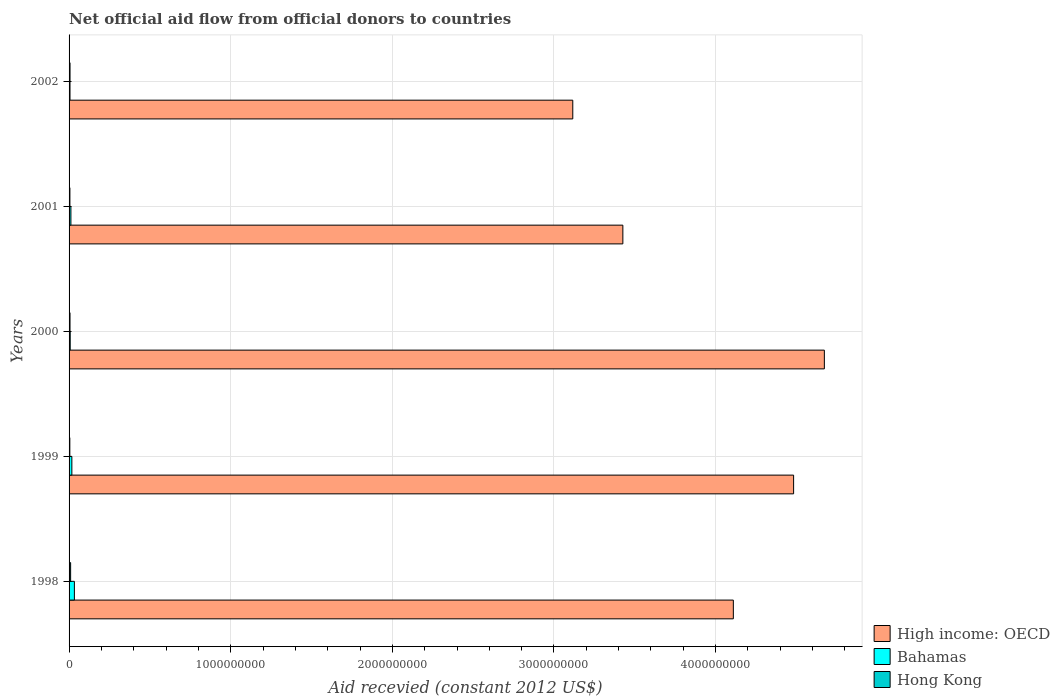Are the number of bars per tick equal to the number of legend labels?
Keep it short and to the point. Yes. Are the number of bars on each tick of the Y-axis equal?
Provide a short and direct response. Yes. How many bars are there on the 3rd tick from the top?
Your answer should be very brief. 3. In how many cases, is the number of bars for a given year not equal to the number of legend labels?
Your answer should be very brief. 0. What is the total aid received in Hong Kong in 1998?
Keep it short and to the point. 9.64e+06. Across all years, what is the maximum total aid received in Bahamas?
Provide a succinct answer. 3.29e+07. Across all years, what is the minimum total aid received in Bahamas?
Your answer should be very brief. 5.78e+06. In which year was the total aid received in Bahamas maximum?
Give a very brief answer. 1998. In which year was the total aid received in High income: OECD minimum?
Keep it short and to the point. 2002. What is the total total aid received in High income: OECD in the graph?
Keep it short and to the point. 1.98e+1. What is the difference between the total aid received in Hong Kong in 1998 and that in 2002?
Make the answer very short. 3.72e+06. What is the difference between the total aid received in Hong Kong in 1998 and the total aid received in Bahamas in 2002?
Offer a very short reply. 3.86e+06. What is the average total aid received in Bahamas per year?
Your answer should be very brief. 1.49e+07. In the year 2002, what is the difference between the total aid received in Hong Kong and total aid received in High income: OECD?
Keep it short and to the point. -3.11e+09. What is the ratio of the total aid received in High income: OECD in 1999 to that in 2002?
Offer a terse response. 1.44. Is the difference between the total aid received in Hong Kong in 2000 and 2002 greater than the difference between the total aid received in High income: OECD in 2000 and 2002?
Make the answer very short. No. What is the difference between the highest and the second highest total aid received in Bahamas?
Ensure brevity in your answer.  1.57e+07. What is the difference between the highest and the lowest total aid received in Hong Kong?
Provide a succinct answer. 4.91e+06. In how many years, is the total aid received in High income: OECD greater than the average total aid received in High income: OECD taken over all years?
Provide a succinct answer. 3. What does the 3rd bar from the top in 2002 represents?
Offer a terse response. High income: OECD. What does the 3rd bar from the bottom in 2002 represents?
Your answer should be compact. Hong Kong. How many bars are there?
Offer a terse response. 15. Does the graph contain grids?
Keep it short and to the point. Yes. Where does the legend appear in the graph?
Your answer should be compact. Bottom right. How are the legend labels stacked?
Keep it short and to the point. Vertical. What is the title of the graph?
Your response must be concise. Net official aid flow from official donors to countries. Does "Korea (Democratic)" appear as one of the legend labels in the graph?
Offer a very short reply. No. What is the label or title of the X-axis?
Your answer should be compact. Aid recevied (constant 2012 US$). What is the label or title of the Y-axis?
Provide a short and direct response. Years. What is the Aid recevied (constant 2012 US$) of High income: OECD in 1998?
Ensure brevity in your answer.  4.11e+09. What is the Aid recevied (constant 2012 US$) in Bahamas in 1998?
Provide a short and direct response. 3.29e+07. What is the Aid recevied (constant 2012 US$) of Hong Kong in 1998?
Your response must be concise. 9.64e+06. What is the Aid recevied (constant 2012 US$) in High income: OECD in 1999?
Your response must be concise. 4.48e+09. What is the Aid recevied (constant 2012 US$) in Bahamas in 1999?
Your answer should be very brief. 1.72e+07. What is the Aid recevied (constant 2012 US$) of Hong Kong in 1999?
Provide a succinct answer. 4.73e+06. What is the Aid recevied (constant 2012 US$) in High income: OECD in 2000?
Offer a terse response. 4.67e+09. What is the Aid recevied (constant 2012 US$) of Bahamas in 2000?
Give a very brief answer. 7.08e+06. What is the Aid recevied (constant 2012 US$) in Hong Kong in 2000?
Your response must be concise. 5.83e+06. What is the Aid recevied (constant 2012 US$) of High income: OECD in 2001?
Your answer should be compact. 3.43e+09. What is the Aid recevied (constant 2012 US$) in Bahamas in 2001?
Your answer should be very brief. 1.14e+07. What is the Aid recevied (constant 2012 US$) in Hong Kong in 2001?
Give a very brief answer. 5.12e+06. What is the Aid recevied (constant 2012 US$) in High income: OECD in 2002?
Provide a short and direct response. 3.12e+09. What is the Aid recevied (constant 2012 US$) of Bahamas in 2002?
Offer a very short reply. 5.78e+06. What is the Aid recevied (constant 2012 US$) of Hong Kong in 2002?
Your answer should be compact. 5.92e+06. Across all years, what is the maximum Aid recevied (constant 2012 US$) in High income: OECD?
Provide a succinct answer. 4.67e+09. Across all years, what is the maximum Aid recevied (constant 2012 US$) in Bahamas?
Give a very brief answer. 3.29e+07. Across all years, what is the maximum Aid recevied (constant 2012 US$) of Hong Kong?
Offer a very short reply. 9.64e+06. Across all years, what is the minimum Aid recevied (constant 2012 US$) of High income: OECD?
Your answer should be very brief. 3.12e+09. Across all years, what is the minimum Aid recevied (constant 2012 US$) in Bahamas?
Make the answer very short. 5.78e+06. Across all years, what is the minimum Aid recevied (constant 2012 US$) of Hong Kong?
Provide a succinct answer. 4.73e+06. What is the total Aid recevied (constant 2012 US$) in High income: OECD in the graph?
Your response must be concise. 1.98e+1. What is the total Aid recevied (constant 2012 US$) of Bahamas in the graph?
Make the answer very short. 7.44e+07. What is the total Aid recevied (constant 2012 US$) of Hong Kong in the graph?
Make the answer very short. 3.12e+07. What is the difference between the Aid recevied (constant 2012 US$) of High income: OECD in 1998 and that in 1999?
Give a very brief answer. -3.73e+08. What is the difference between the Aid recevied (constant 2012 US$) in Bahamas in 1998 and that in 1999?
Your answer should be very brief. 1.57e+07. What is the difference between the Aid recevied (constant 2012 US$) in Hong Kong in 1998 and that in 1999?
Ensure brevity in your answer.  4.91e+06. What is the difference between the Aid recevied (constant 2012 US$) in High income: OECD in 1998 and that in 2000?
Offer a terse response. -5.63e+08. What is the difference between the Aid recevied (constant 2012 US$) of Bahamas in 1998 and that in 2000?
Provide a short and direct response. 2.58e+07. What is the difference between the Aid recevied (constant 2012 US$) in Hong Kong in 1998 and that in 2000?
Your response must be concise. 3.81e+06. What is the difference between the Aid recevied (constant 2012 US$) in High income: OECD in 1998 and that in 2001?
Offer a terse response. 6.84e+08. What is the difference between the Aid recevied (constant 2012 US$) in Bahamas in 1998 and that in 2001?
Offer a terse response. 2.15e+07. What is the difference between the Aid recevied (constant 2012 US$) in Hong Kong in 1998 and that in 2001?
Offer a terse response. 4.52e+06. What is the difference between the Aid recevied (constant 2012 US$) of High income: OECD in 1998 and that in 2002?
Your answer should be very brief. 9.93e+08. What is the difference between the Aid recevied (constant 2012 US$) in Bahamas in 1998 and that in 2002?
Your response must be concise. 2.71e+07. What is the difference between the Aid recevied (constant 2012 US$) in Hong Kong in 1998 and that in 2002?
Ensure brevity in your answer.  3.72e+06. What is the difference between the Aid recevied (constant 2012 US$) of High income: OECD in 1999 and that in 2000?
Your answer should be very brief. -1.90e+08. What is the difference between the Aid recevied (constant 2012 US$) in Bahamas in 1999 and that in 2000?
Your response must be concise. 1.02e+07. What is the difference between the Aid recevied (constant 2012 US$) in Hong Kong in 1999 and that in 2000?
Ensure brevity in your answer.  -1.10e+06. What is the difference between the Aid recevied (constant 2012 US$) of High income: OECD in 1999 and that in 2001?
Keep it short and to the point. 1.06e+09. What is the difference between the Aid recevied (constant 2012 US$) of Bahamas in 1999 and that in 2001?
Your answer should be compact. 5.86e+06. What is the difference between the Aid recevied (constant 2012 US$) of Hong Kong in 1999 and that in 2001?
Offer a terse response. -3.90e+05. What is the difference between the Aid recevied (constant 2012 US$) of High income: OECD in 1999 and that in 2002?
Offer a very short reply. 1.37e+09. What is the difference between the Aid recevied (constant 2012 US$) in Bahamas in 1999 and that in 2002?
Your response must be concise. 1.15e+07. What is the difference between the Aid recevied (constant 2012 US$) of Hong Kong in 1999 and that in 2002?
Give a very brief answer. -1.19e+06. What is the difference between the Aid recevied (constant 2012 US$) of High income: OECD in 2000 and that in 2001?
Provide a succinct answer. 1.25e+09. What is the difference between the Aid recevied (constant 2012 US$) of Bahamas in 2000 and that in 2001?
Your response must be concise. -4.30e+06. What is the difference between the Aid recevied (constant 2012 US$) in Hong Kong in 2000 and that in 2001?
Your answer should be very brief. 7.10e+05. What is the difference between the Aid recevied (constant 2012 US$) in High income: OECD in 2000 and that in 2002?
Keep it short and to the point. 1.56e+09. What is the difference between the Aid recevied (constant 2012 US$) of Bahamas in 2000 and that in 2002?
Your response must be concise. 1.30e+06. What is the difference between the Aid recevied (constant 2012 US$) of Hong Kong in 2000 and that in 2002?
Give a very brief answer. -9.00e+04. What is the difference between the Aid recevied (constant 2012 US$) in High income: OECD in 2001 and that in 2002?
Provide a succinct answer. 3.10e+08. What is the difference between the Aid recevied (constant 2012 US$) of Bahamas in 2001 and that in 2002?
Your answer should be compact. 5.60e+06. What is the difference between the Aid recevied (constant 2012 US$) in Hong Kong in 2001 and that in 2002?
Your answer should be compact. -8.00e+05. What is the difference between the Aid recevied (constant 2012 US$) in High income: OECD in 1998 and the Aid recevied (constant 2012 US$) in Bahamas in 1999?
Ensure brevity in your answer.  4.09e+09. What is the difference between the Aid recevied (constant 2012 US$) in High income: OECD in 1998 and the Aid recevied (constant 2012 US$) in Hong Kong in 1999?
Keep it short and to the point. 4.10e+09. What is the difference between the Aid recevied (constant 2012 US$) of Bahamas in 1998 and the Aid recevied (constant 2012 US$) of Hong Kong in 1999?
Ensure brevity in your answer.  2.82e+07. What is the difference between the Aid recevied (constant 2012 US$) of High income: OECD in 1998 and the Aid recevied (constant 2012 US$) of Bahamas in 2000?
Give a very brief answer. 4.10e+09. What is the difference between the Aid recevied (constant 2012 US$) of High income: OECD in 1998 and the Aid recevied (constant 2012 US$) of Hong Kong in 2000?
Provide a short and direct response. 4.10e+09. What is the difference between the Aid recevied (constant 2012 US$) of Bahamas in 1998 and the Aid recevied (constant 2012 US$) of Hong Kong in 2000?
Make the answer very short. 2.71e+07. What is the difference between the Aid recevied (constant 2012 US$) of High income: OECD in 1998 and the Aid recevied (constant 2012 US$) of Bahamas in 2001?
Your answer should be very brief. 4.10e+09. What is the difference between the Aid recevied (constant 2012 US$) of High income: OECD in 1998 and the Aid recevied (constant 2012 US$) of Hong Kong in 2001?
Provide a short and direct response. 4.10e+09. What is the difference between the Aid recevied (constant 2012 US$) of Bahamas in 1998 and the Aid recevied (constant 2012 US$) of Hong Kong in 2001?
Keep it short and to the point. 2.78e+07. What is the difference between the Aid recevied (constant 2012 US$) of High income: OECD in 1998 and the Aid recevied (constant 2012 US$) of Bahamas in 2002?
Your answer should be very brief. 4.10e+09. What is the difference between the Aid recevied (constant 2012 US$) in High income: OECD in 1998 and the Aid recevied (constant 2012 US$) in Hong Kong in 2002?
Offer a terse response. 4.10e+09. What is the difference between the Aid recevied (constant 2012 US$) of Bahamas in 1998 and the Aid recevied (constant 2012 US$) of Hong Kong in 2002?
Provide a succinct answer. 2.70e+07. What is the difference between the Aid recevied (constant 2012 US$) of High income: OECD in 1999 and the Aid recevied (constant 2012 US$) of Bahamas in 2000?
Provide a short and direct response. 4.48e+09. What is the difference between the Aid recevied (constant 2012 US$) in High income: OECD in 1999 and the Aid recevied (constant 2012 US$) in Hong Kong in 2000?
Your answer should be very brief. 4.48e+09. What is the difference between the Aid recevied (constant 2012 US$) in Bahamas in 1999 and the Aid recevied (constant 2012 US$) in Hong Kong in 2000?
Offer a very short reply. 1.14e+07. What is the difference between the Aid recevied (constant 2012 US$) of High income: OECD in 1999 and the Aid recevied (constant 2012 US$) of Bahamas in 2001?
Your answer should be very brief. 4.47e+09. What is the difference between the Aid recevied (constant 2012 US$) of High income: OECD in 1999 and the Aid recevied (constant 2012 US$) of Hong Kong in 2001?
Give a very brief answer. 4.48e+09. What is the difference between the Aid recevied (constant 2012 US$) of Bahamas in 1999 and the Aid recevied (constant 2012 US$) of Hong Kong in 2001?
Keep it short and to the point. 1.21e+07. What is the difference between the Aid recevied (constant 2012 US$) in High income: OECD in 1999 and the Aid recevied (constant 2012 US$) in Bahamas in 2002?
Ensure brevity in your answer.  4.48e+09. What is the difference between the Aid recevied (constant 2012 US$) in High income: OECD in 1999 and the Aid recevied (constant 2012 US$) in Hong Kong in 2002?
Make the answer very short. 4.48e+09. What is the difference between the Aid recevied (constant 2012 US$) in Bahamas in 1999 and the Aid recevied (constant 2012 US$) in Hong Kong in 2002?
Keep it short and to the point. 1.13e+07. What is the difference between the Aid recevied (constant 2012 US$) in High income: OECD in 2000 and the Aid recevied (constant 2012 US$) in Bahamas in 2001?
Your answer should be compact. 4.66e+09. What is the difference between the Aid recevied (constant 2012 US$) of High income: OECD in 2000 and the Aid recevied (constant 2012 US$) of Hong Kong in 2001?
Your answer should be very brief. 4.67e+09. What is the difference between the Aid recevied (constant 2012 US$) in Bahamas in 2000 and the Aid recevied (constant 2012 US$) in Hong Kong in 2001?
Make the answer very short. 1.96e+06. What is the difference between the Aid recevied (constant 2012 US$) in High income: OECD in 2000 and the Aid recevied (constant 2012 US$) in Bahamas in 2002?
Offer a terse response. 4.67e+09. What is the difference between the Aid recevied (constant 2012 US$) of High income: OECD in 2000 and the Aid recevied (constant 2012 US$) of Hong Kong in 2002?
Your answer should be compact. 4.67e+09. What is the difference between the Aid recevied (constant 2012 US$) in Bahamas in 2000 and the Aid recevied (constant 2012 US$) in Hong Kong in 2002?
Make the answer very short. 1.16e+06. What is the difference between the Aid recevied (constant 2012 US$) in High income: OECD in 2001 and the Aid recevied (constant 2012 US$) in Bahamas in 2002?
Offer a very short reply. 3.42e+09. What is the difference between the Aid recevied (constant 2012 US$) of High income: OECD in 2001 and the Aid recevied (constant 2012 US$) of Hong Kong in 2002?
Your response must be concise. 3.42e+09. What is the difference between the Aid recevied (constant 2012 US$) of Bahamas in 2001 and the Aid recevied (constant 2012 US$) of Hong Kong in 2002?
Offer a terse response. 5.46e+06. What is the average Aid recevied (constant 2012 US$) of High income: OECD per year?
Your answer should be compact. 3.96e+09. What is the average Aid recevied (constant 2012 US$) in Bahamas per year?
Keep it short and to the point. 1.49e+07. What is the average Aid recevied (constant 2012 US$) in Hong Kong per year?
Offer a very short reply. 6.25e+06. In the year 1998, what is the difference between the Aid recevied (constant 2012 US$) in High income: OECD and Aid recevied (constant 2012 US$) in Bahamas?
Offer a terse response. 4.08e+09. In the year 1998, what is the difference between the Aid recevied (constant 2012 US$) in High income: OECD and Aid recevied (constant 2012 US$) in Hong Kong?
Make the answer very short. 4.10e+09. In the year 1998, what is the difference between the Aid recevied (constant 2012 US$) of Bahamas and Aid recevied (constant 2012 US$) of Hong Kong?
Offer a very short reply. 2.33e+07. In the year 1999, what is the difference between the Aid recevied (constant 2012 US$) in High income: OECD and Aid recevied (constant 2012 US$) in Bahamas?
Provide a succinct answer. 4.47e+09. In the year 1999, what is the difference between the Aid recevied (constant 2012 US$) in High income: OECD and Aid recevied (constant 2012 US$) in Hong Kong?
Your answer should be compact. 4.48e+09. In the year 1999, what is the difference between the Aid recevied (constant 2012 US$) of Bahamas and Aid recevied (constant 2012 US$) of Hong Kong?
Your answer should be compact. 1.25e+07. In the year 2000, what is the difference between the Aid recevied (constant 2012 US$) of High income: OECD and Aid recevied (constant 2012 US$) of Bahamas?
Your answer should be compact. 4.67e+09. In the year 2000, what is the difference between the Aid recevied (constant 2012 US$) in High income: OECD and Aid recevied (constant 2012 US$) in Hong Kong?
Offer a very short reply. 4.67e+09. In the year 2000, what is the difference between the Aid recevied (constant 2012 US$) in Bahamas and Aid recevied (constant 2012 US$) in Hong Kong?
Your answer should be compact. 1.25e+06. In the year 2001, what is the difference between the Aid recevied (constant 2012 US$) of High income: OECD and Aid recevied (constant 2012 US$) of Bahamas?
Give a very brief answer. 3.41e+09. In the year 2001, what is the difference between the Aid recevied (constant 2012 US$) of High income: OECD and Aid recevied (constant 2012 US$) of Hong Kong?
Offer a very short reply. 3.42e+09. In the year 2001, what is the difference between the Aid recevied (constant 2012 US$) of Bahamas and Aid recevied (constant 2012 US$) of Hong Kong?
Offer a terse response. 6.26e+06. In the year 2002, what is the difference between the Aid recevied (constant 2012 US$) of High income: OECD and Aid recevied (constant 2012 US$) of Bahamas?
Make the answer very short. 3.11e+09. In the year 2002, what is the difference between the Aid recevied (constant 2012 US$) in High income: OECD and Aid recevied (constant 2012 US$) in Hong Kong?
Provide a short and direct response. 3.11e+09. What is the ratio of the Aid recevied (constant 2012 US$) of High income: OECD in 1998 to that in 1999?
Your response must be concise. 0.92. What is the ratio of the Aid recevied (constant 2012 US$) of Bahamas in 1998 to that in 1999?
Make the answer very short. 1.91. What is the ratio of the Aid recevied (constant 2012 US$) of Hong Kong in 1998 to that in 1999?
Provide a succinct answer. 2.04. What is the ratio of the Aid recevied (constant 2012 US$) in High income: OECD in 1998 to that in 2000?
Make the answer very short. 0.88. What is the ratio of the Aid recevied (constant 2012 US$) in Bahamas in 1998 to that in 2000?
Your answer should be compact. 4.65. What is the ratio of the Aid recevied (constant 2012 US$) in Hong Kong in 1998 to that in 2000?
Ensure brevity in your answer.  1.65. What is the ratio of the Aid recevied (constant 2012 US$) in High income: OECD in 1998 to that in 2001?
Provide a succinct answer. 1.2. What is the ratio of the Aid recevied (constant 2012 US$) in Bahamas in 1998 to that in 2001?
Offer a terse response. 2.89. What is the ratio of the Aid recevied (constant 2012 US$) in Hong Kong in 1998 to that in 2001?
Give a very brief answer. 1.88. What is the ratio of the Aid recevied (constant 2012 US$) of High income: OECD in 1998 to that in 2002?
Provide a short and direct response. 1.32. What is the ratio of the Aid recevied (constant 2012 US$) in Bahamas in 1998 to that in 2002?
Keep it short and to the point. 5.69. What is the ratio of the Aid recevied (constant 2012 US$) of Hong Kong in 1998 to that in 2002?
Offer a very short reply. 1.63. What is the ratio of the Aid recevied (constant 2012 US$) in High income: OECD in 1999 to that in 2000?
Your response must be concise. 0.96. What is the ratio of the Aid recevied (constant 2012 US$) in Bahamas in 1999 to that in 2000?
Offer a terse response. 2.44. What is the ratio of the Aid recevied (constant 2012 US$) of Hong Kong in 1999 to that in 2000?
Provide a short and direct response. 0.81. What is the ratio of the Aid recevied (constant 2012 US$) in High income: OECD in 1999 to that in 2001?
Make the answer very short. 1.31. What is the ratio of the Aid recevied (constant 2012 US$) of Bahamas in 1999 to that in 2001?
Offer a terse response. 1.51. What is the ratio of the Aid recevied (constant 2012 US$) of Hong Kong in 1999 to that in 2001?
Keep it short and to the point. 0.92. What is the ratio of the Aid recevied (constant 2012 US$) of High income: OECD in 1999 to that in 2002?
Your response must be concise. 1.44. What is the ratio of the Aid recevied (constant 2012 US$) in Bahamas in 1999 to that in 2002?
Make the answer very short. 2.98. What is the ratio of the Aid recevied (constant 2012 US$) of Hong Kong in 1999 to that in 2002?
Ensure brevity in your answer.  0.8. What is the ratio of the Aid recevied (constant 2012 US$) of High income: OECD in 2000 to that in 2001?
Offer a terse response. 1.36. What is the ratio of the Aid recevied (constant 2012 US$) in Bahamas in 2000 to that in 2001?
Keep it short and to the point. 0.62. What is the ratio of the Aid recevied (constant 2012 US$) of Hong Kong in 2000 to that in 2001?
Your response must be concise. 1.14. What is the ratio of the Aid recevied (constant 2012 US$) of High income: OECD in 2000 to that in 2002?
Offer a very short reply. 1.5. What is the ratio of the Aid recevied (constant 2012 US$) in Bahamas in 2000 to that in 2002?
Offer a terse response. 1.22. What is the ratio of the Aid recevied (constant 2012 US$) in High income: OECD in 2001 to that in 2002?
Make the answer very short. 1.1. What is the ratio of the Aid recevied (constant 2012 US$) of Bahamas in 2001 to that in 2002?
Offer a very short reply. 1.97. What is the ratio of the Aid recevied (constant 2012 US$) of Hong Kong in 2001 to that in 2002?
Make the answer very short. 0.86. What is the difference between the highest and the second highest Aid recevied (constant 2012 US$) of High income: OECD?
Give a very brief answer. 1.90e+08. What is the difference between the highest and the second highest Aid recevied (constant 2012 US$) in Bahamas?
Provide a short and direct response. 1.57e+07. What is the difference between the highest and the second highest Aid recevied (constant 2012 US$) of Hong Kong?
Provide a short and direct response. 3.72e+06. What is the difference between the highest and the lowest Aid recevied (constant 2012 US$) of High income: OECD?
Offer a terse response. 1.56e+09. What is the difference between the highest and the lowest Aid recevied (constant 2012 US$) in Bahamas?
Make the answer very short. 2.71e+07. What is the difference between the highest and the lowest Aid recevied (constant 2012 US$) in Hong Kong?
Provide a short and direct response. 4.91e+06. 